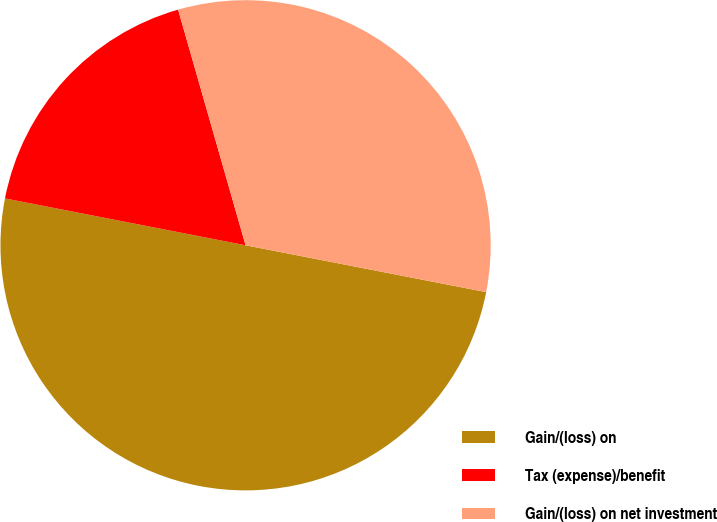Convert chart. <chart><loc_0><loc_0><loc_500><loc_500><pie_chart><fcel>Gain/(loss) on<fcel>Tax (expense)/benefit<fcel>Gain/(loss) on net investment<nl><fcel>50.0%<fcel>17.5%<fcel>32.5%<nl></chart> 